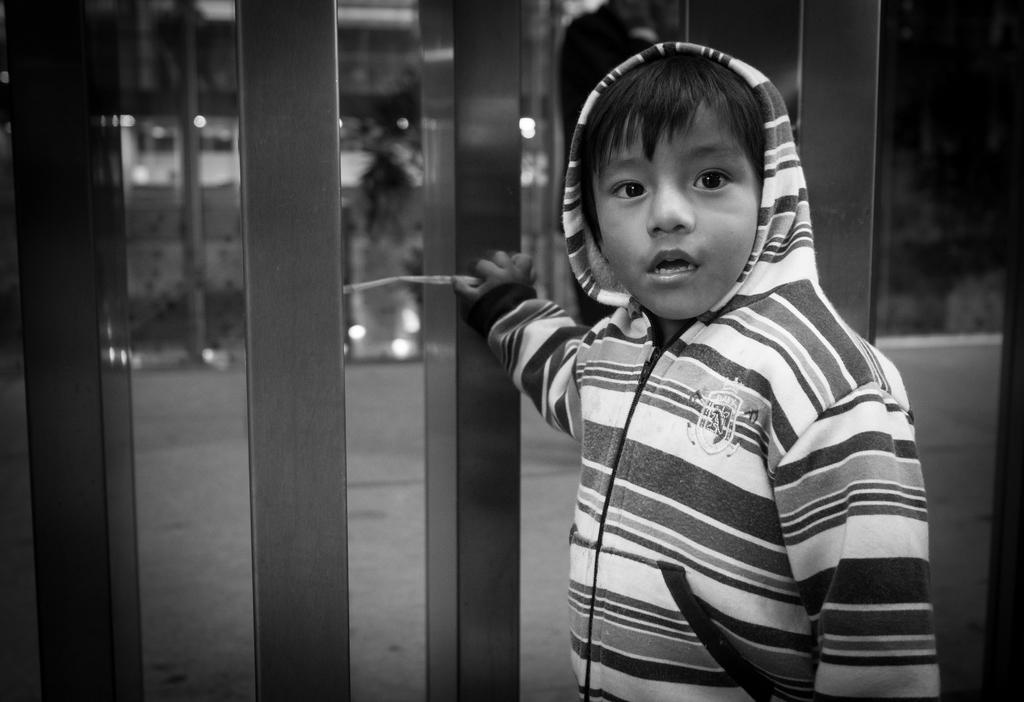What is the color scheme of the image? The image is black and white. What objects can be seen in the image? There are poles in the image. What is the kid in the image doing? The kid is holding one of the poles. Can you describe the background of the image? The background of the image is blurred. What else can be seen in the image besides the poles and the kid? There are lights visible in the image. How many eyes does the hydrant have in the image? There is no hydrant present in the image, so it is not possible to determine how many eyes it might have. Are the kid's sisters visible in the image? There is no mention of the kid having sisters, and no other children are visible in the image. 